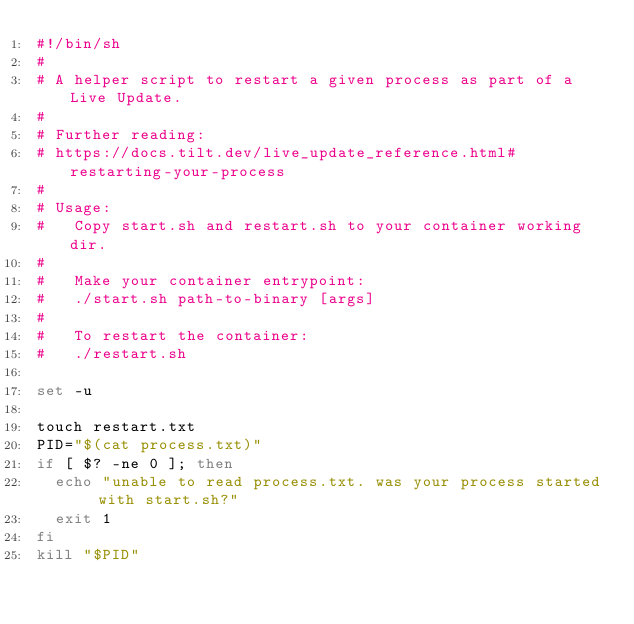Convert code to text. <code><loc_0><loc_0><loc_500><loc_500><_Bash_>#!/bin/sh
#
# A helper script to restart a given process as part of a Live Update.
#
# Further reading:
# https://docs.tilt.dev/live_update_reference.html#restarting-your-process
#
# Usage:
#   Copy start.sh and restart.sh to your container working dir.
#
#   Make your container entrypoint:
#   ./start.sh path-to-binary [args]
#
#   To restart the container:
#   ./restart.sh

set -u

touch restart.txt
PID="$(cat process.txt)"
if [ $? -ne 0 ]; then
  echo "unable to read process.txt. was your process started with start.sh?"
  exit 1
fi
kill "$PID"
</code> 